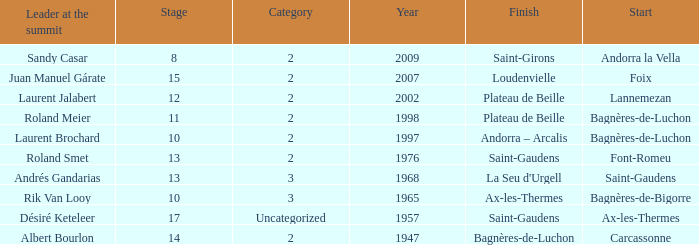Name the start of an event in Catagory 2 of the year 1947. Carcassonne. 